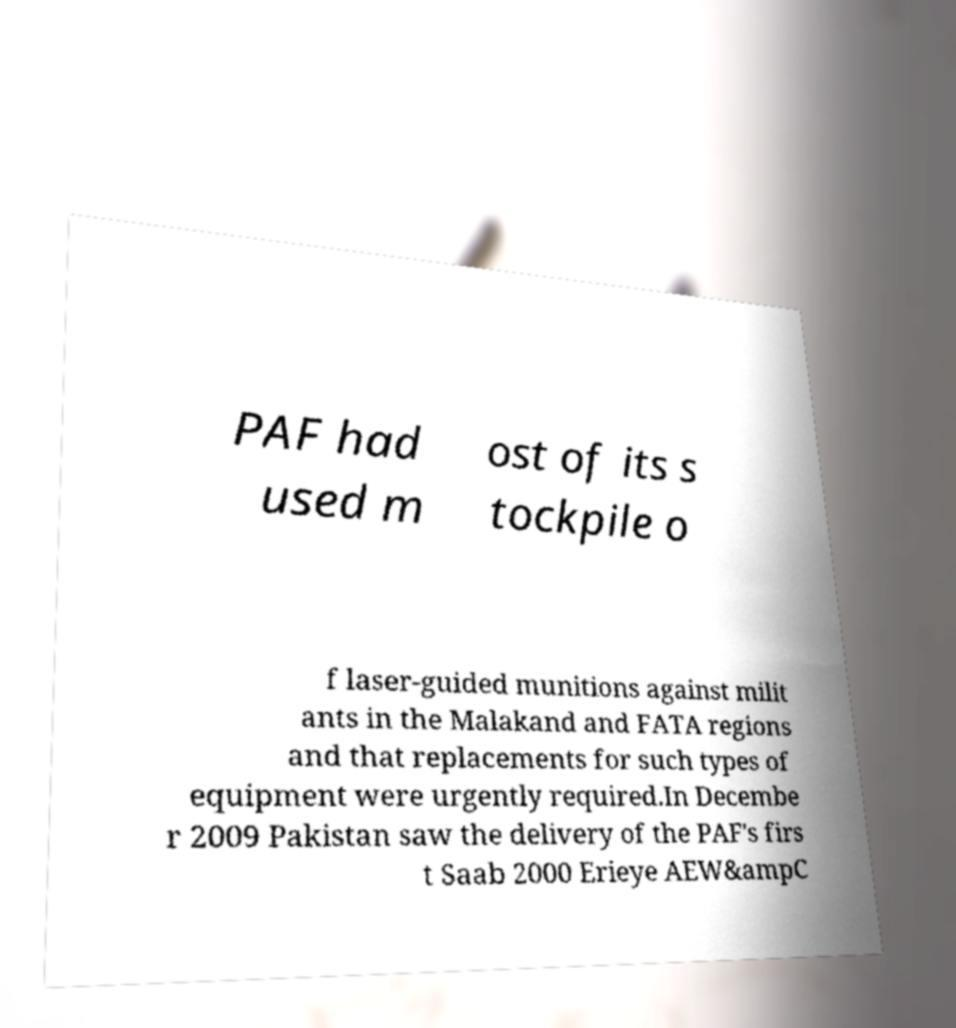For documentation purposes, I need the text within this image transcribed. Could you provide that? PAF had used m ost of its s tockpile o f laser-guided munitions against milit ants in the Malakand and FATA regions and that replacements for such types of equipment were urgently required.In Decembe r 2009 Pakistan saw the delivery of the PAF's firs t Saab 2000 Erieye AEW&ampC 